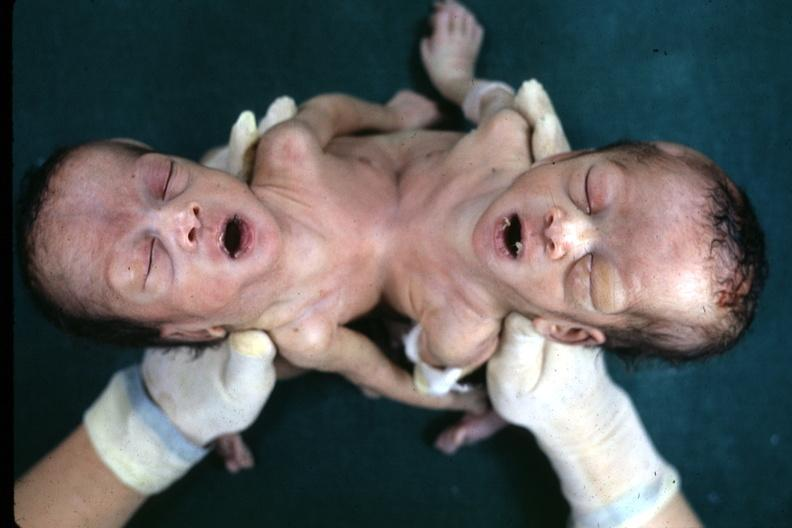what is present?
Answer the question using a single word or phrase. Siamese twins 